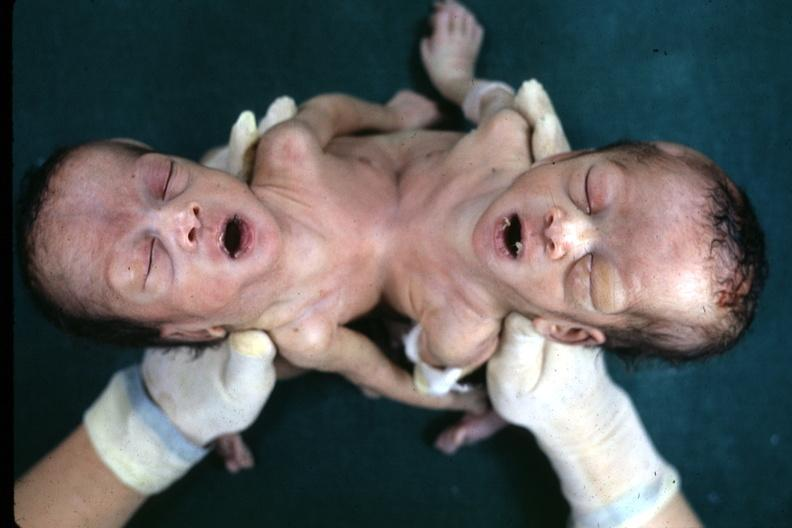what is present?
Answer the question using a single word or phrase. Siamese twins 